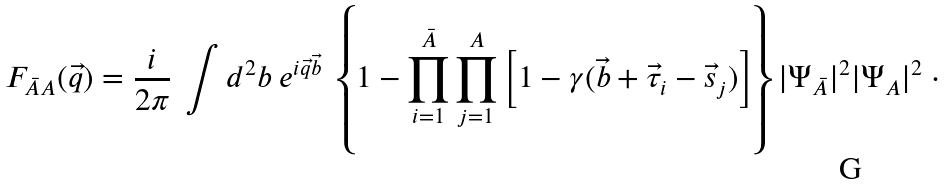<formula> <loc_0><loc_0><loc_500><loc_500>F _ { \bar { A } A } ( \vec { q } ) = \frac { i } { 2 \pi } \ \int d ^ { 2 } b \ e ^ { i \vec { q } \vec { b } } \ \left \{ 1 - \prod ^ { \bar { A } } _ { i = 1 } \prod ^ { A } _ { j = 1 } \left [ 1 - \gamma ( \vec { b } + \vec { \tau } _ { i } - \vec { s } _ { j } ) \right ] \right \} | \Psi _ { \bar { A } } | ^ { 2 } | \Psi _ { A } | ^ { 2 } \ \cdot</formula> 